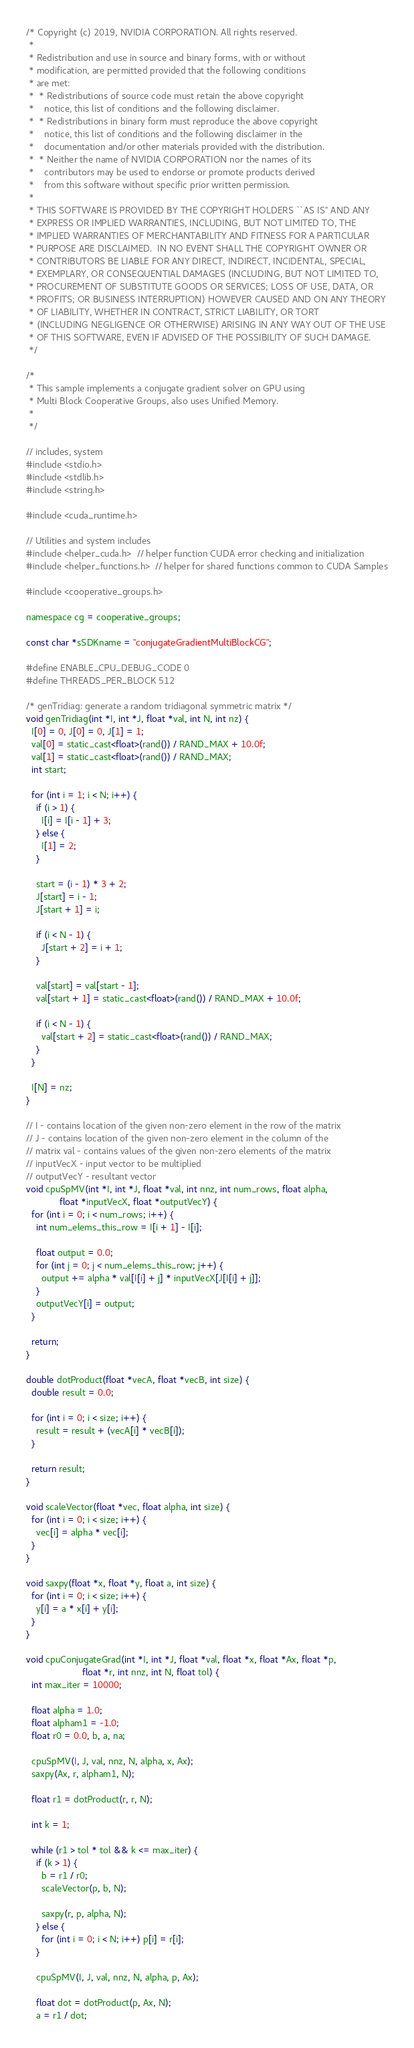Convert code to text. <code><loc_0><loc_0><loc_500><loc_500><_Cuda_>/* Copyright (c) 2019, NVIDIA CORPORATION. All rights reserved.
 *
 * Redistribution and use in source and binary forms, with or without
 * modification, are permitted provided that the following conditions
 * are met:
 *  * Redistributions of source code must retain the above copyright
 *    notice, this list of conditions and the following disclaimer.
 *  * Redistributions in binary form must reproduce the above copyright
 *    notice, this list of conditions and the following disclaimer in the
 *    documentation and/or other materials provided with the distribution.
 *  * Neither the name of NVIDIA CORPORATION nor the names of its
 *    contributors may be used to endorse or promote products derived
 *    from this software without specific prior written permission.
 *
 * THIS SOFTWARE IS PROVIDED BY THE COPYRIGHT HOLDERS ``AS IS'' AND ANY
 * EXPRESS OR IMPLIED WARRANTIES, INCLUDING, BUT NOT LIMITED TO, THE
 * IMPLIED WARRANTIES OF MERCHANTABILITY AND FITNESS FOR A PARTICULAR
 * PURPOSE ARE DISCLAIMED.  IN NO EVENT SHALL THE COPYRIGHT OWNER OR
 * CONTRIBUTORS BE LIABLE FOR ANY DIRECT, INDIRECT, INCIDENTAL, SPECIAL,
 * EXEMPLARY, OR CONSEQUENTIAL DAMAGES (INCLUDING, BUT NOT LIMITED TO,
 * PROCUREMENT OF SUBSTITUTE GOODS OR SERVICES; LOSS OF USE, DATA, OR
 * PROFITS; OR BUSINESS INTERRUPTION) HOWEVER CAUSED AND ON ANY THEORY
 * OF LIABILITY, WHETHER IN CONTRACT, STRICT LIABILITY, OR TORT
 * (INCLUDING NEGLIGENCE OR OTHERWISE) ARISING IN ANY WAY OUT OF THE USE
 * OF THIS SOFTWARE, EVEN IF ADVISED OF THE POSSIBILITY OF SUCH DAMAGE.
 */

/*
 * This sample implements a conjugate gradient solver on GPU using
 * Multi Block Cooperative Groups, also uses Unified Memory.
 *
 */

// includes, system
#include <stdio.h>
#include <stdlib.h>
#include <string.h>

#include <cuda_runtime.h>

// Utilities and system includes
#include <helper_cuda.h>  // helper function CUDA error checking and initialization
#include <helper_functions.h>  // helper for shared functions common to CUDA Samples

#include <cooperative_groups.h>

namespace cg = cooperative_groups;

const char *sSDKname = "conjugateGradientMultiBlockCG";

#define ENABLE_CPU_DEBUG_CODE 0
#define THREADS_PER_BLOCK 512

/* genTridiag: generate a random tridiagonal symmetric matrix */
void genTridiag(int *I, int *J, float *val, int N, int nz) {
  I[0] = 0, J[0] = 0, J[1] = 1;
  val[0] = static_cast<float>(rand()) / RAND_MAX + 10.0f;
  val[1] = static_cast<float>(rand()) / RAND_MAX;
  int start;

  for (int i = 1; i < N; i++) {
    if (i > 1) {
      I[i] = I[i - 1] + 3;
    } else {
      I[1] = 2;
    }

    start = (i - 1) * 3 + 2;
    J[start] = i - 1;
    J[start + 1] = i;

    if (i < N - 1) {
      J[start + 2] = i + 1;
    }

    val[start] = val[start - 1];
    val[start + 1] = static_cast<float>(rand()) / RAND_MAX + 10.0f;

    if (i < N - 1) {
      val[start + 2] = static_cast<float>(rand()) / RAND_MAX;
    }
  }

  I[N] = nz;
}

// I - contains location of the given non-zero element in the row of the matrix
// J - contains location of the given non-zero element in the column of the
// matrix val - contains values of the given non-zero elements of the matrix
// inputVecX - input vector to be multiplied
// outputVecY - resultant vector
void cpuSpMV(int *I, int *J, float *val, int nnz, int num_rows, float alpha,
             float *inputVecX, float *outputVecY) {
  for (int i = 0; i < num_rows; i++) {
    int num_elems_this_row = I[i + 1] - I[i];

    float output = 0.0;
    for (int j = 0; j < num_elems_this_row; j++) {
      output += alpha * val[I[i] + j] * inputVecX[J[I[i] + j]];
    }
    outputVecY[i] = output;
  }

  return;
}

double dotProduct(float *vecA, float *vecB, int size) {
  double result = 0.0;

  for (int i = 0; i < size; i++) {
    result = result + (vecA[i] * vecB[i]);
  }

  return result;
}

void scaleVector(float *vec, float alpha, int size) {
  for (int i = 0; i < size; i++) {
    vec[i] = alpha * vec[i];
  }
}

void saxpy(float *x, float *y, float a, int size) {
  for (int i = 0; i < size; i++) {
    y[i] = a * x[i] + y[i];
  }
}

void cpuConjugateGrad(int *I, int *J, float *val, float *x, float *Ax, float *p,
                      float *r, int nnz, int N, float tol) {
  int max_iter = 10000;

  float alpha = 1.0;
  float alpham1 = -1.0;
  float r0 = 0.0, b, a, na;

  cpuSpMV(I, J, val, nnz, N, alpha, x, Ax);
  saxpy(Ax, r, alpham1, N);

  float r1 = dotProduct(r, r, N);

  int k = 1;

  while (r1 > tol * tol && k <= max_iter) {
    if (k > 1) {
      b = r1 / r0;
      scaleVector(p, b, N);

      saxpy(r, p, alpha, N);
    } else {
      for (int i = 0; i < N; i++) p[i] = r[i];
    }

    cpuSpMV(I, J, val, nnz, N, alpha, p, Ax);

    float dot = dotProduct(p, Ax, N);
    a = r1 / dot;
</code> 